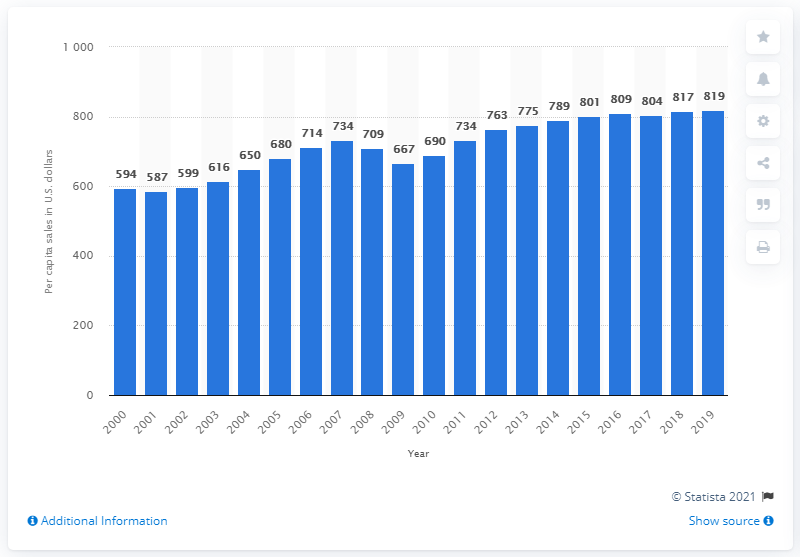Identify some key points in this picture. In 2019, the per capita sales of clothing and clothing accessories in the United States was 819. 